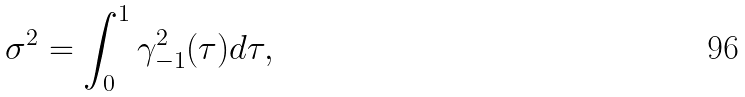Convert formula to latex. <formula><loc_0><loc_0><loc_500><loc_500>\sigma ^ { 2 } = \int _ { 0 } ^ { 1 } \gamma _ { - 1 } ^ { 2 } ( \tau ) d \tau ,</formula> 